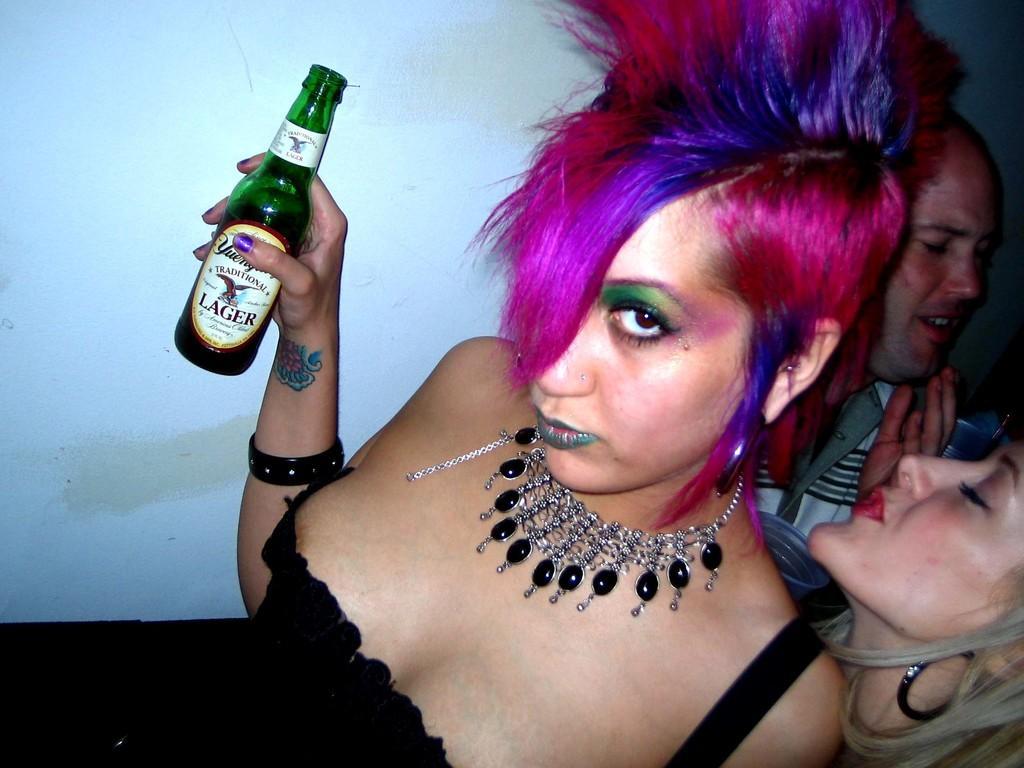Please provide a concise description of this image. there is a woman with pink hair holding and alcohol bottle behind her there is an other men and a girl standing. 